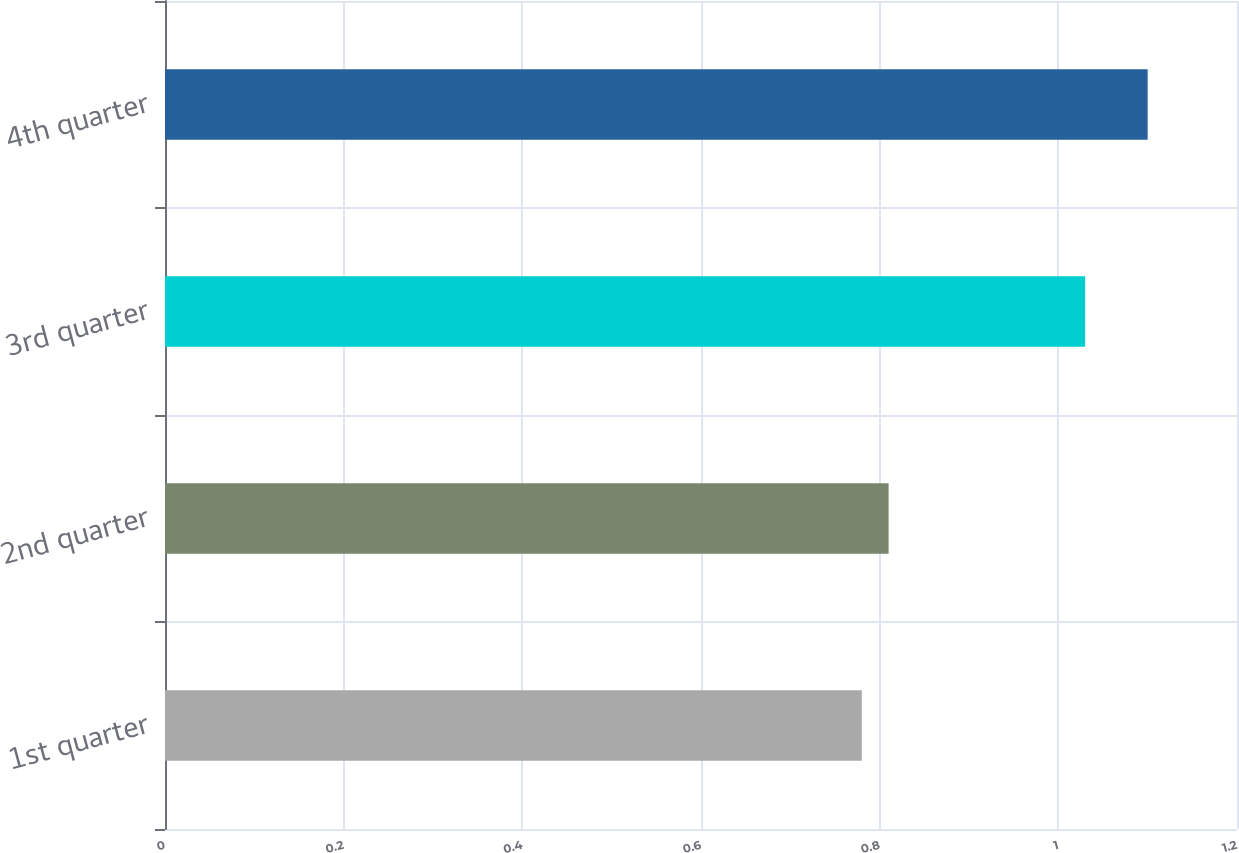<chart> <loc_0><loc_0><loc_500><loc_500><bar_chart><fcel>1st quarter<fcel>2nd quarter<fcel>3rd quarter<fcel>4th quarter<nl><fcel>0.78<fcel>0.81<fcel>1.03<fcel>1.1<nl></chart> 